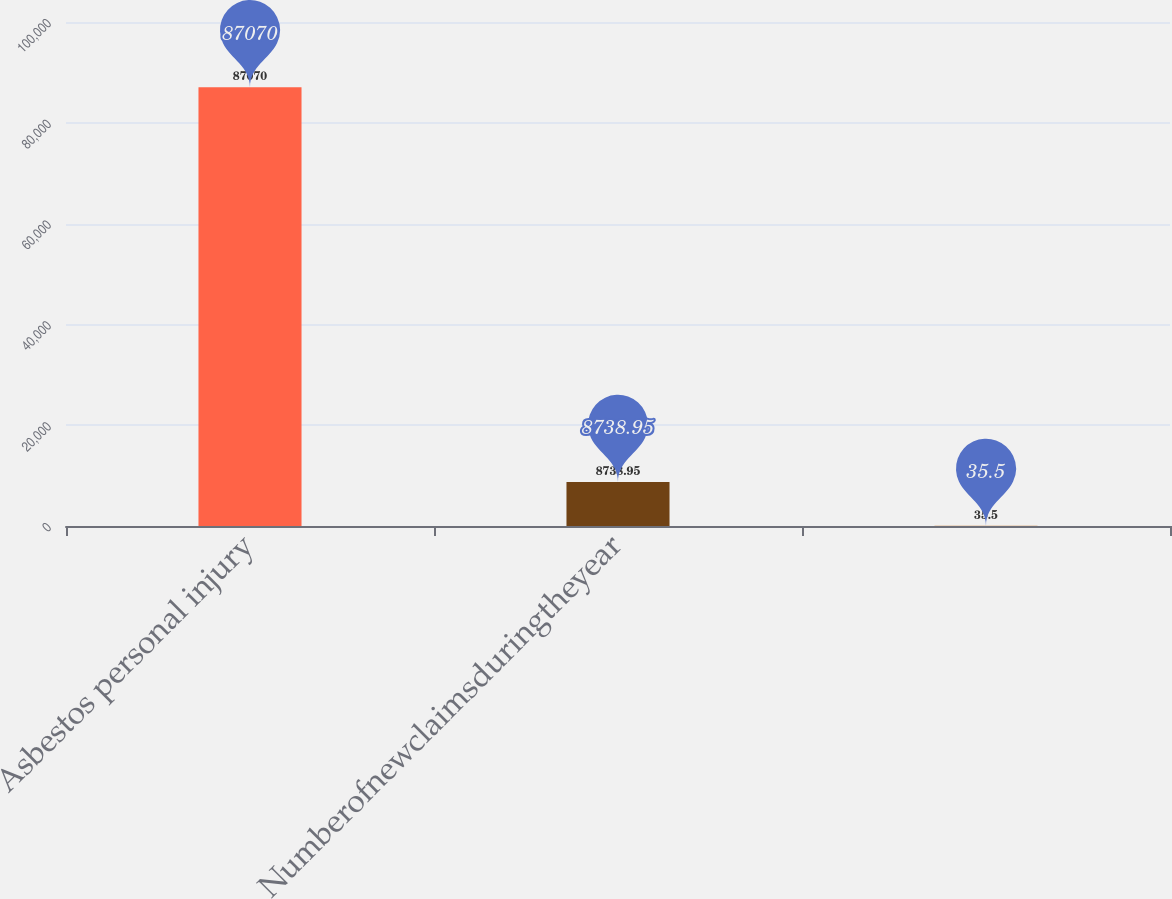Convert chart. <chart><loc_0><loc_0><loc_500><loc_500><bar_chart><fcel>Asbestos personal injury<fcel>Numberofnewclaimsduringtheyear<fcel>Unnamed: 2<nl><fcel>87070<fcel>8738.95<fcel>35.5<nl></chart> 